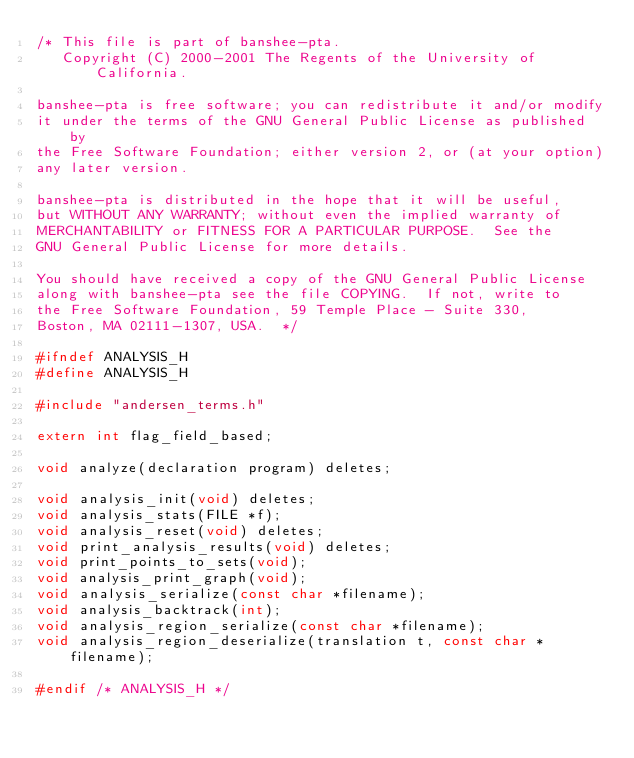Convert code to text. <code><loc_0><loc_0><loc_500><loc_500><_C_>/* This file is part of banshee-pta.
   Copyright (C) 2000-2001 The Regents of the University of California.

banshee-pta is free software; you can redistribute it and/or modify
it under the terms of the GNU General Public License as published by
the Free Software Foundation; either version 2, or (at your option)
any later version.

banshee-pta is distributed in the hope that it will be useful,
but WITHOUT ANY WARRANTY; without even the implied warranty of
MERCHANTABILITY or FITNESS FOR A PARTICULAR PURPOSE.  See the
GNU General Public License for more details.

You should have received a copy of the GNU General Public License
along with banshee-pta see the file COPYING.  If not, write to
the Free Software Foundation, 59 Temple Place - Suite 330,
Boston, MA 02111-1307, USA.  */

#ifndef ANALYSIS_H
#define ANALYSIS_H

#include "andersen_terms.h"

extern int flag_field_based;

void analyze(declaration program) deletes;

void analysis_init(void) deletes;
void analysis_stats(FILE *f);
void analysis_reset(void) deletes;
void print_analysis_results(void) deletes;
void print_points_to_sets(void);
void analysis_print_graph(void);
void analysis_serialize(const char *filename);
void analysis_backtrack(int);
void analysis_region_serialize(const char *filename);
void analysis_region_deserialize(translation t, const char *filename);

#endif /* ANALYSIS_H */
</code> 